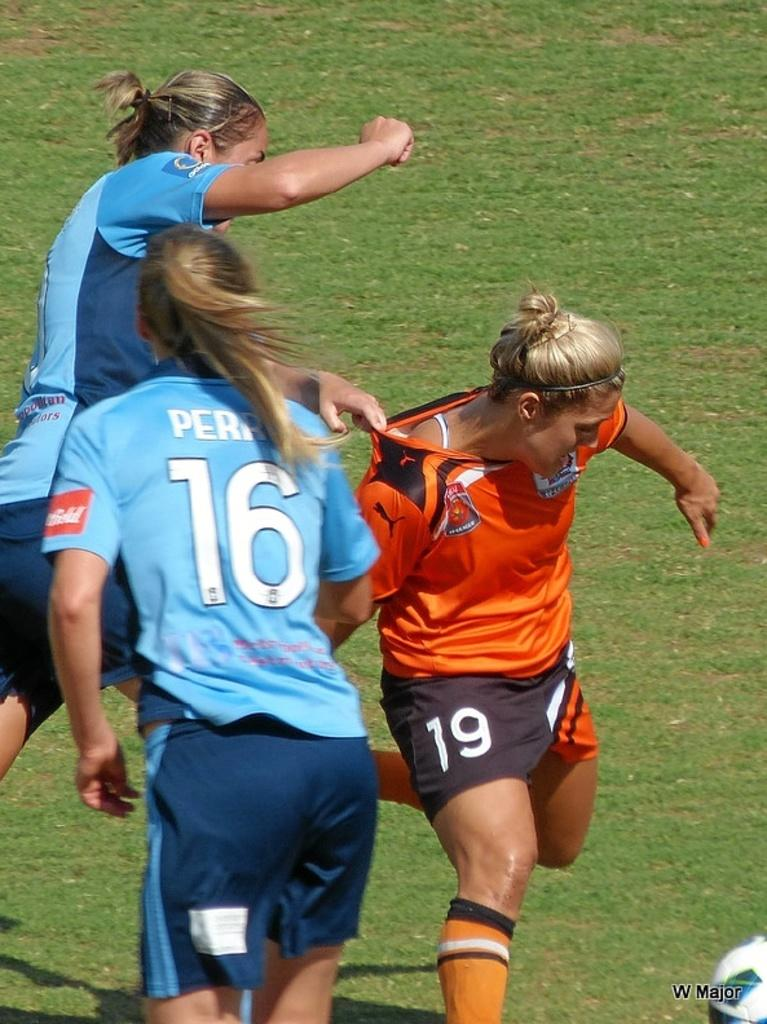<image>
Share a concise interpretation of the image provided. a few people playing soccer with one wearing 16 